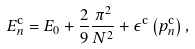Convert formula to latex. <formula><loc_0><loc_0><loc_500><loc_500>E _ { n } ^ { \text {c} } = E _ { 0 } + \frac { 2 } { 9 } \frac { \pi ^ { 2 } } { N ^ { 2 } } + \epsilon ^ { \text {c} } \left ( p ^ { \text {c} } _ { n } \right ) ,</formula> 